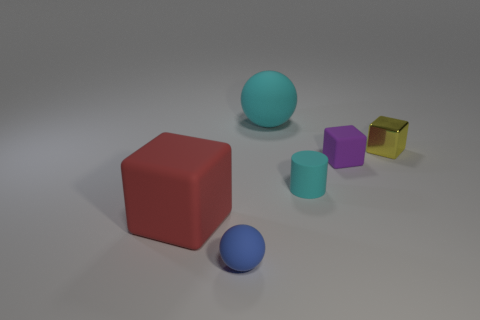There is a rubber cylinder that is the same size as the blue matte object; what color is it?
Give a very brief answer. Cyan. There is a cyan object behind the purple matte thing; what is its size?
Make the answer very short. Large. There is a ball that is in front of the cyan rubber cylinder; is there a ball that is to the left of it?
Your answer should be compact. No. Is the material of the object that is in front of the red object the same as the big cyan object?
Your answer should be compact. Yes. How many objects are behind the small blue matte ball and on the left side of the yellow thing?
Give a very brief answer. 4. What number of small brown balls have the same material as the large red block?
Provide a succinct answer. 0. There is a tiny block that is the same material as the big red thing; what color is it?
Your response must be concise. Purple. Is the number of big cyan objects less than the number of large purple cubes?
Offer a terse response. No. What is the material of the cube on the left side of the ball in front of the cyan object in front of the large cyan matte ball?
Your answer should be very brief. Rubber. What material is the small blue thing?
Your answer should be compact. Rubber. 